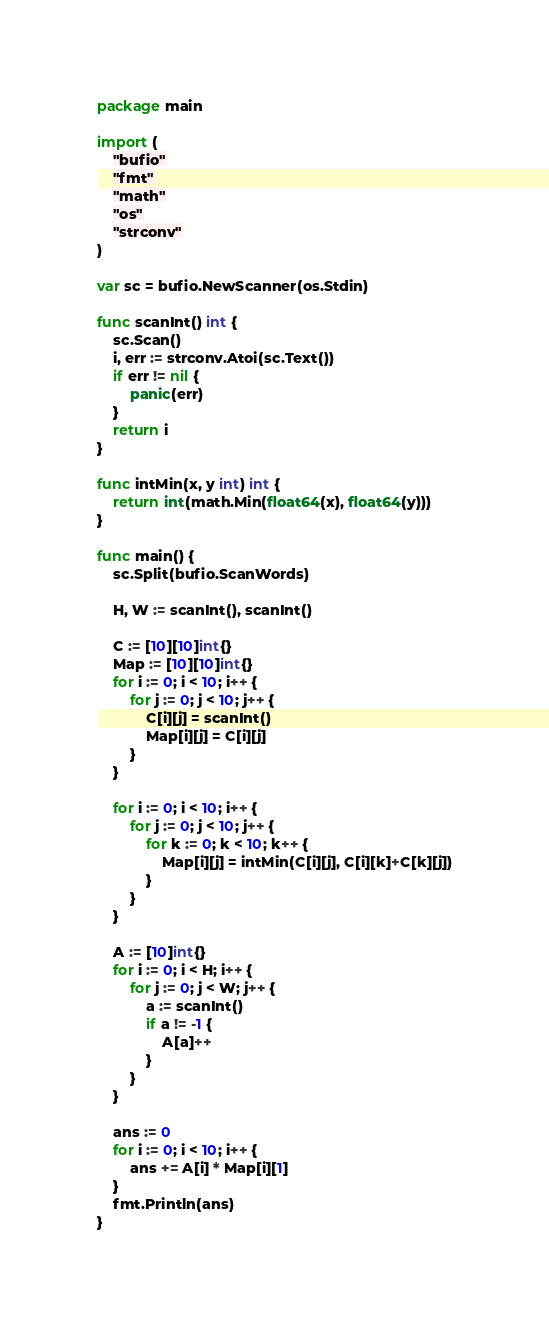Convert code to text. <code><loc_0><loc_0><loc_500><loc_500><_Go_>package main

import (
	"bufio"
	"fmt"
	"math"
	"os"
	"strconv"
)

var sc = bufio.NewScanner(os.Stdin)

func scanInt() int {
	sc.Scan()
	i, err := strconv.Atoi(sc.Text())
	if err != nil {
		panic(err)
	}
	return i
}

func intMin(x, y int) int {
	return int(math.Min(float64(x), float64(y)))
}

func main() {
	sc.Split(bufio.ScanWords)

	H, W := scanInt(), scanInt()

	C := [10][10]int{}
	Map := [10][10]int{}
	for i := 0; i < 10; i++ {
		for j := 0; j < 10; j++ {
			C[i][j] = scanInt()
			Map[i][j] = C[i][j]
		}
	}

	for i := 0; i < 10; i++ {
		for j := 0; j < 10; j++ {
			for k := 0; k < 10; k++ {
				Map[i][j] = intMin(C[i][j], C[i][k]+C[k][j])
			}
		}
	}

	A := [10]int{}
	for i := 0; i < H; i++ {
		for j := 0; j < W; j++ {
			a := scanInt()
			if a != -1 {
				A[a]++
			}
		}
	}

	ans := 0
	for i := 0; i < 10; i++ {
		ans += A[i] * Map[i][1]
	}
	fmt.Println(ans)
}
</code> 